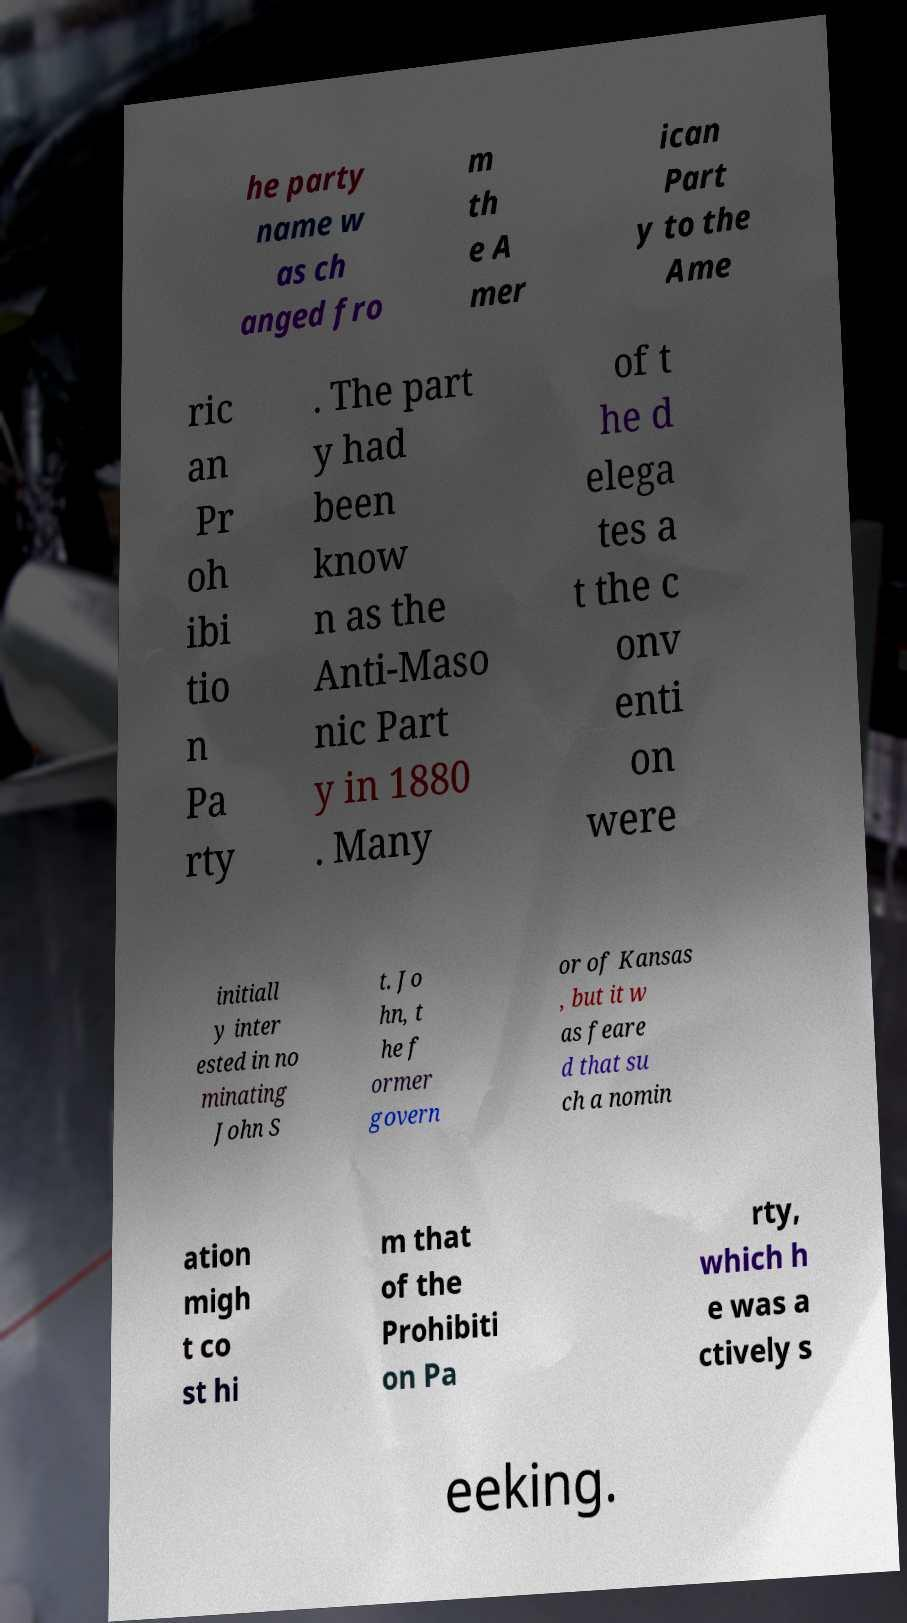Can you read and provide the text displayed in the image?This photo seems to have some interesting text. Can you extract and type it out for me? he party name w as ch anged fro m th e A mer ican Part y to the Ame ric an Pr oh ibi tio n Pa rty . The part y had been know n as the Anti-Maso nic Part y in 1880 . Many of t he d elega tes a t the c onv enti on were initiall y inter ested in no minating John S t. Jo hn, t he f ormer govern or of Kansas , but it w as feare d that su ch a nomin ation migh t co st hi m that of the Prohibiti on Pa rty, which h e was a ctively s eeking. 